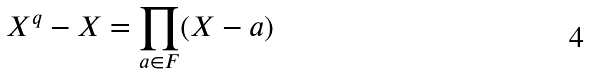<formula> <loc_0><loc_0><loc_500><loc_500>X ^ { q } - X = \prod _ { a \in F } ( X - a )</formula> 